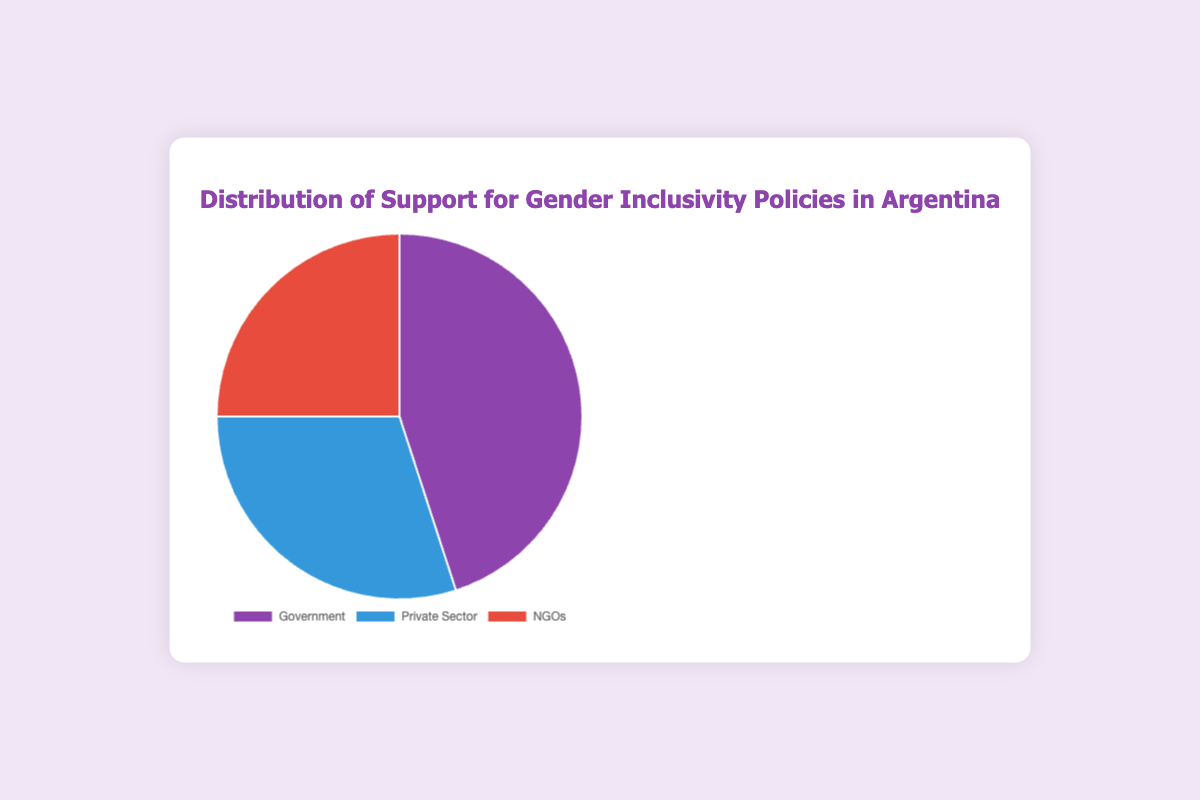What is the percentage of support from the Government? The Government's support percentage is directly mentioned in the figure. Look at the segment labeled 'Government' to find the percentage.
Answer: 45% Which sector has the least support for gender inclusivity policies? Compare the percentages of support for the Government, Private Sector, and NGOs. The one with the smallest percentage is the answer.
Answer: NGOs What is the total percentage of support from the Private Sector and NGOs combined? Add the percentages of the Private Sector and NGOs together: 30% (Private Sector) + 25% (NGOs) = 55%.
Answer: 55% How does the support from the Government compare to the support from the Private Sector? Compare the percentages provided. The Government has 45% support, and the Private Sector has 30% support. The Government has more support for gender inclusivity policies.
Answer: Government has more support What is the color representation for the Private Sector? Look at the chart and identify the color associated with the Private Sector segment.
Answer: Blue Is the support from NGOs greater than 20%? Check the percentage value of the NGOs segment in the pie chart. It is 25%, which is greater than 20%.
Answer: Yes What percentage of the total support does the largest segment represent? Identify the segment with the largest percentage, which is the Government with 45%.
Answer: 45% Which group’s support is closest to 25%? Look at the segments and their percentages. The NGOs’ support is 25%, which is exactly 25%.
Answer: NGOs How much more support does the Government have compared to NGOs? Subtract the support percentage of NGOs from that of the Government: 45% (Government) - 25% (NGOs) = 20%.
Answer: 20% What is the sum of support percentages across all sectors? Add the percentages of the Government, Private Sector, and NGOs together: 45% + 30% + 25% = 100%.
Answer: 100% 